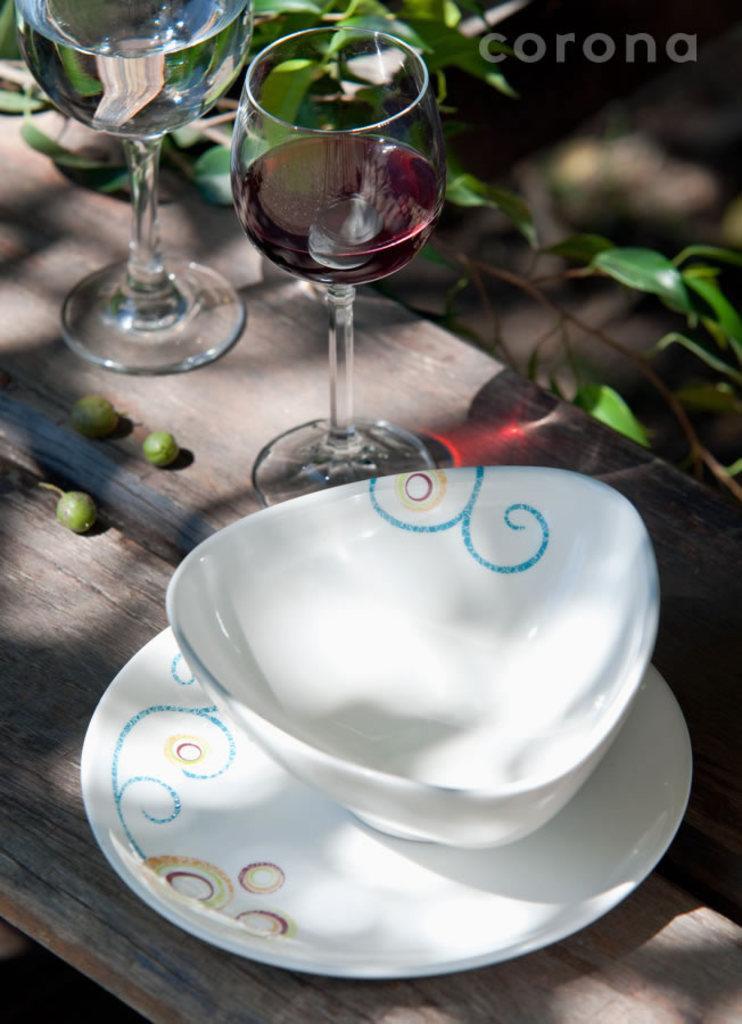Please provide a concise description of this image. In this image I can see two glasses, plate, bowl and fruits on a table. In the background I can see creepers and text. This image is taken, may be during a day. 